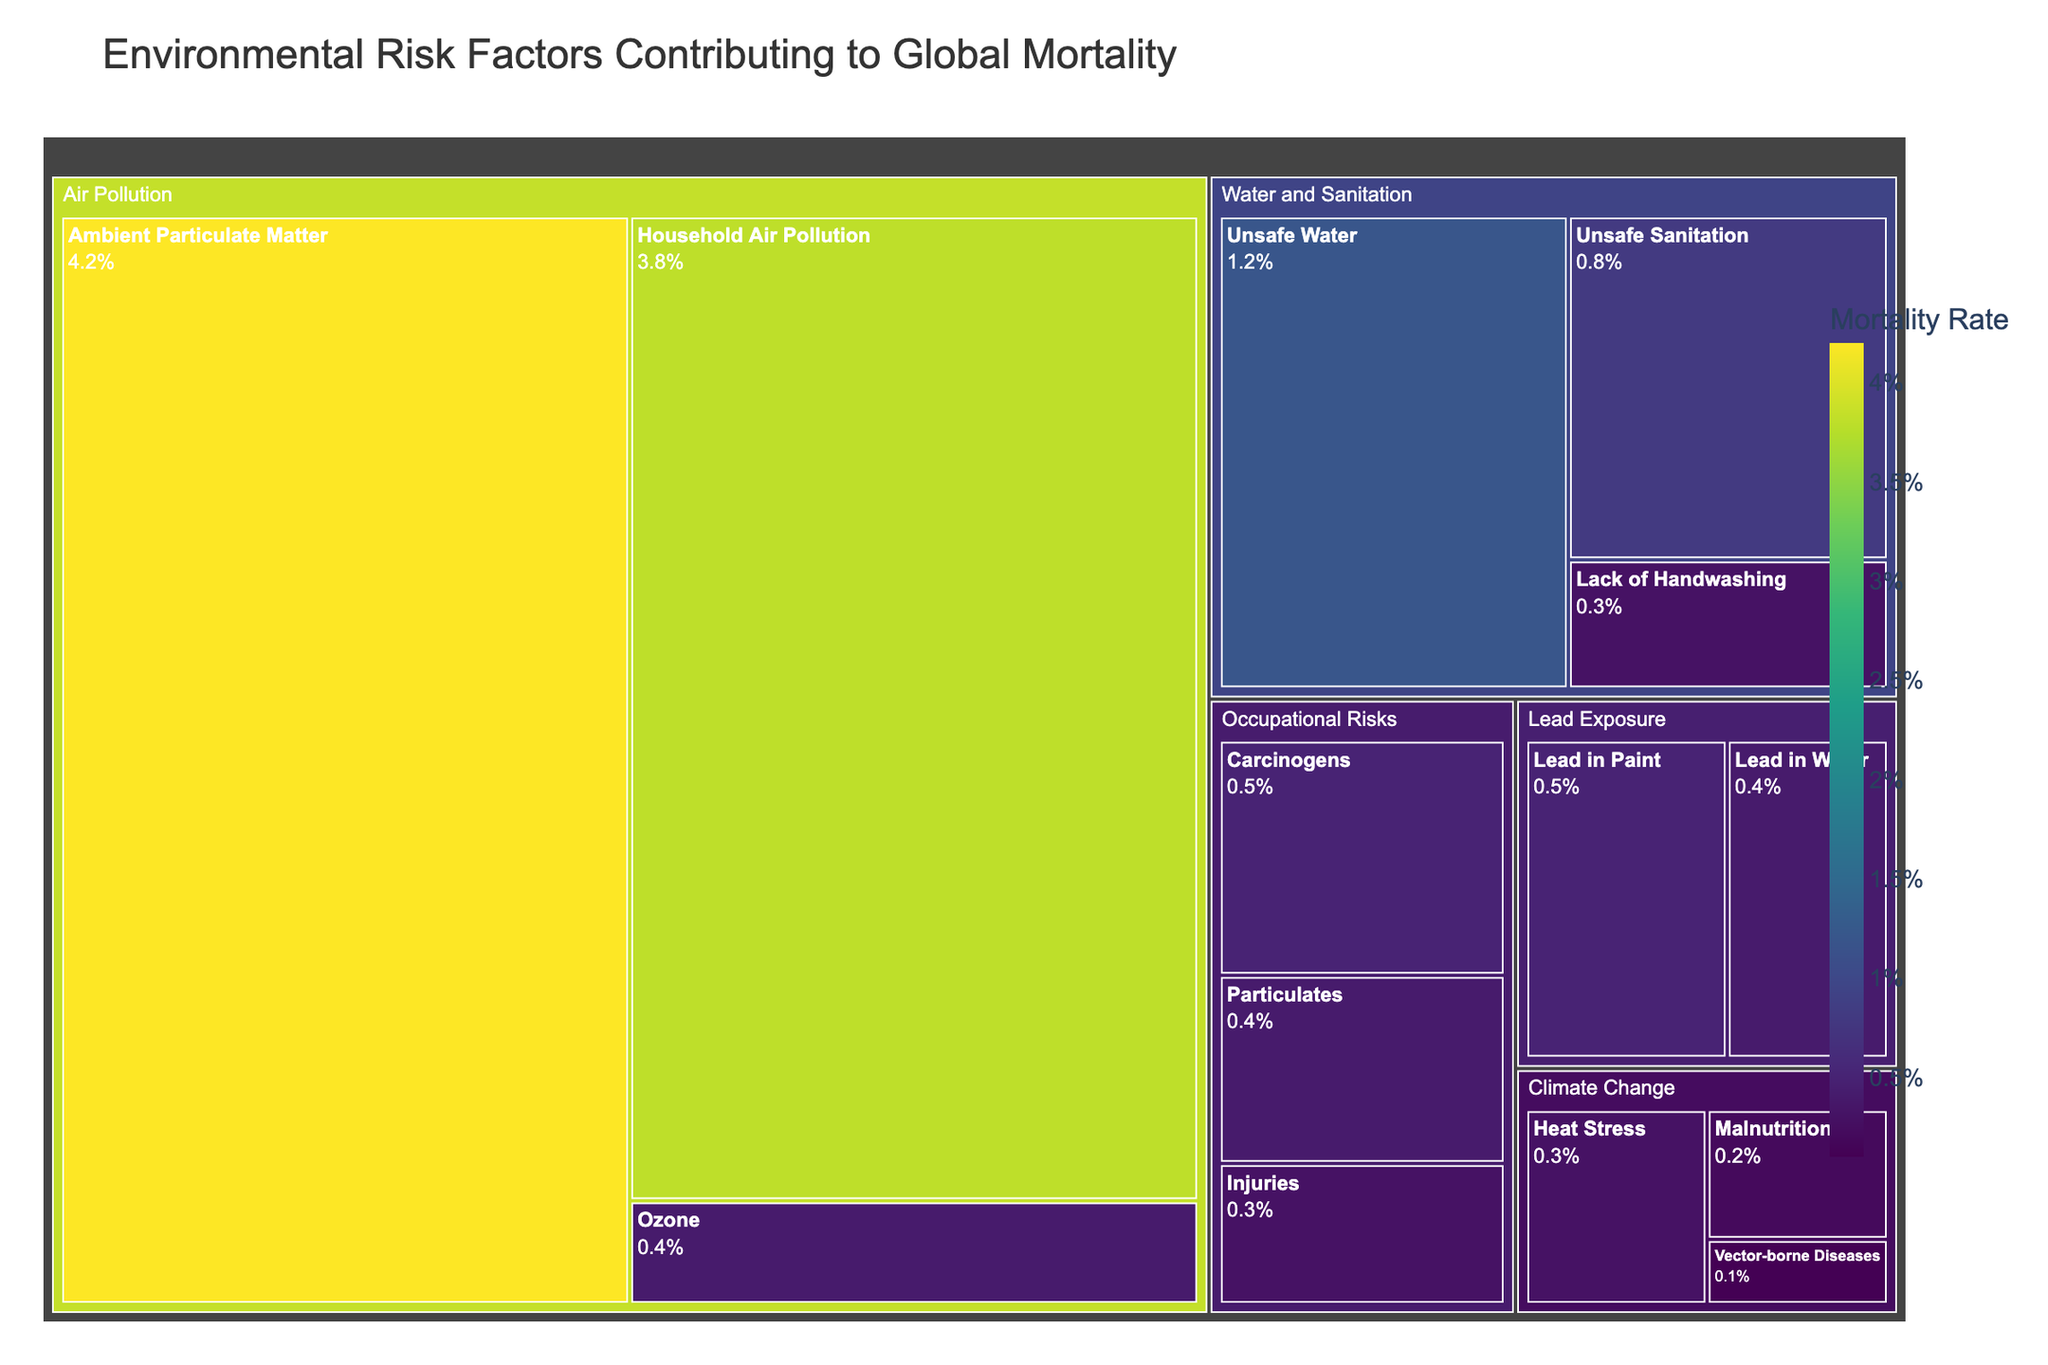What is the title of the treemap? The title of the treemap is displayed at the top and is typically a brief explanation of what the figure represents. Here, the title reads "Environmental Risk Factors Contributing to Global Mortality."
Answer: Environmental Risk Factors Contributing to Global Mortality Which category has the highest mortality rate? To determine the category with the highest mortality rate, look for the largest block in the treemap. The "Air Pollution" category is the largest, indicating it has the highest cumulative mortality rate.
Answer: Air Pollution Among the subcategories of Air Pollution, which one has the lowest mortality rate? Within the "Air Pollution" category, examine the relative sizes of the blocks representing each subcategory. "Ozone" is the smallest block, signifying the lowest mortality rate in this category.
Answer: Ozone What is the combined mortality rate for all Water and Sanitation subcategories? The Water and Sanitation category includes "Unsafe Water," "Unsafe Sanitation," and "Lack of Handwashing" with mortality rates of 1.2, 0.8, and 0.3 respectively. The combined rate is the sum: 1.2 + 0.8 + 0.3 = 2.3.
Answer: 2.3 How does the mortality rate from Ambient Particulate Matter compare to that from Lead in Paint? Compare the sizes of the blocks for "Ambient Particulate Matter" under "Air Pollution" and "Lead in Paint" under "Lead Exposure." "Ambient Particulate Matter" (4.2) has a higher mortality rate than "Lead in Paint" (0.5).
Answer: Ambient Particulate Matter has a higher rate Which subcategory under Occupational Risks has the smallest mortality rate? Inspect the subcategories under "Occupational Risks" and compare their relative sizes. "Injuries," "Carcinogens," and "Particulates" are represented, with "Injuries" being the smallest, indicating the lowest mortality rate among them (0.3).
Answer: Injuries What is the value of the subcategory with the highest mortality rate in Climate Change? In the "Climate Change" category, observe the blocks' sizes. "Heat Stress" is the largest, representing the highest mortality rate, which is 0.3.
Answer: 0.3 Is the total mortality rate for Lead Exposure greater than that for Occupational Risks? Summing up the values for "Lead Exposure" (0.5 + 0.4 = 0.9) and "Occupational Risks" (0.5 + 0.4 + 0.3 = 1.2) reveals that the total for Occupational Risks is higher.
Answer: No, Occupational Risks is higher What is the difference in mortality rates between Heat Stress and Malnutrition under Climate Change? Subtract the rate for "Malnutrition" (0.2) from "Heat Stress" (0.3), which results in 0.3 - 0.2 = 0.1.
Answer: 0.1 